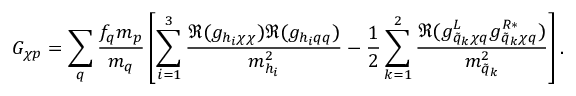<formula> <loc_0><loc_0><loc_500><loc_500>G _ { \chi p } = \sum _ { q } { \frac { f _ { q } m _ { p } } { m _ { q } } } \left [ \sum _ { i = 1 } ^ { 3 } { \frac { \Re ( g _ { h _ { i } \chi \chi } ) \Re ( g _ { h _ { i } q q } ) } { m _ { h _ { i } } ^ { 2 } } } - { \frac { 1 } { 2 } } \sum _ { k = 1 } ^ { 2 } { \frac { \Re ( g _ { \tilde { q } _ { k } \chi q } ^ { L } g _ { \tilde { q } _ { k } \chi q } ^ { R * } ) } { m _ { \tilde { q } _ { k } } ^ { 2 } } } \right ] .</formula> 